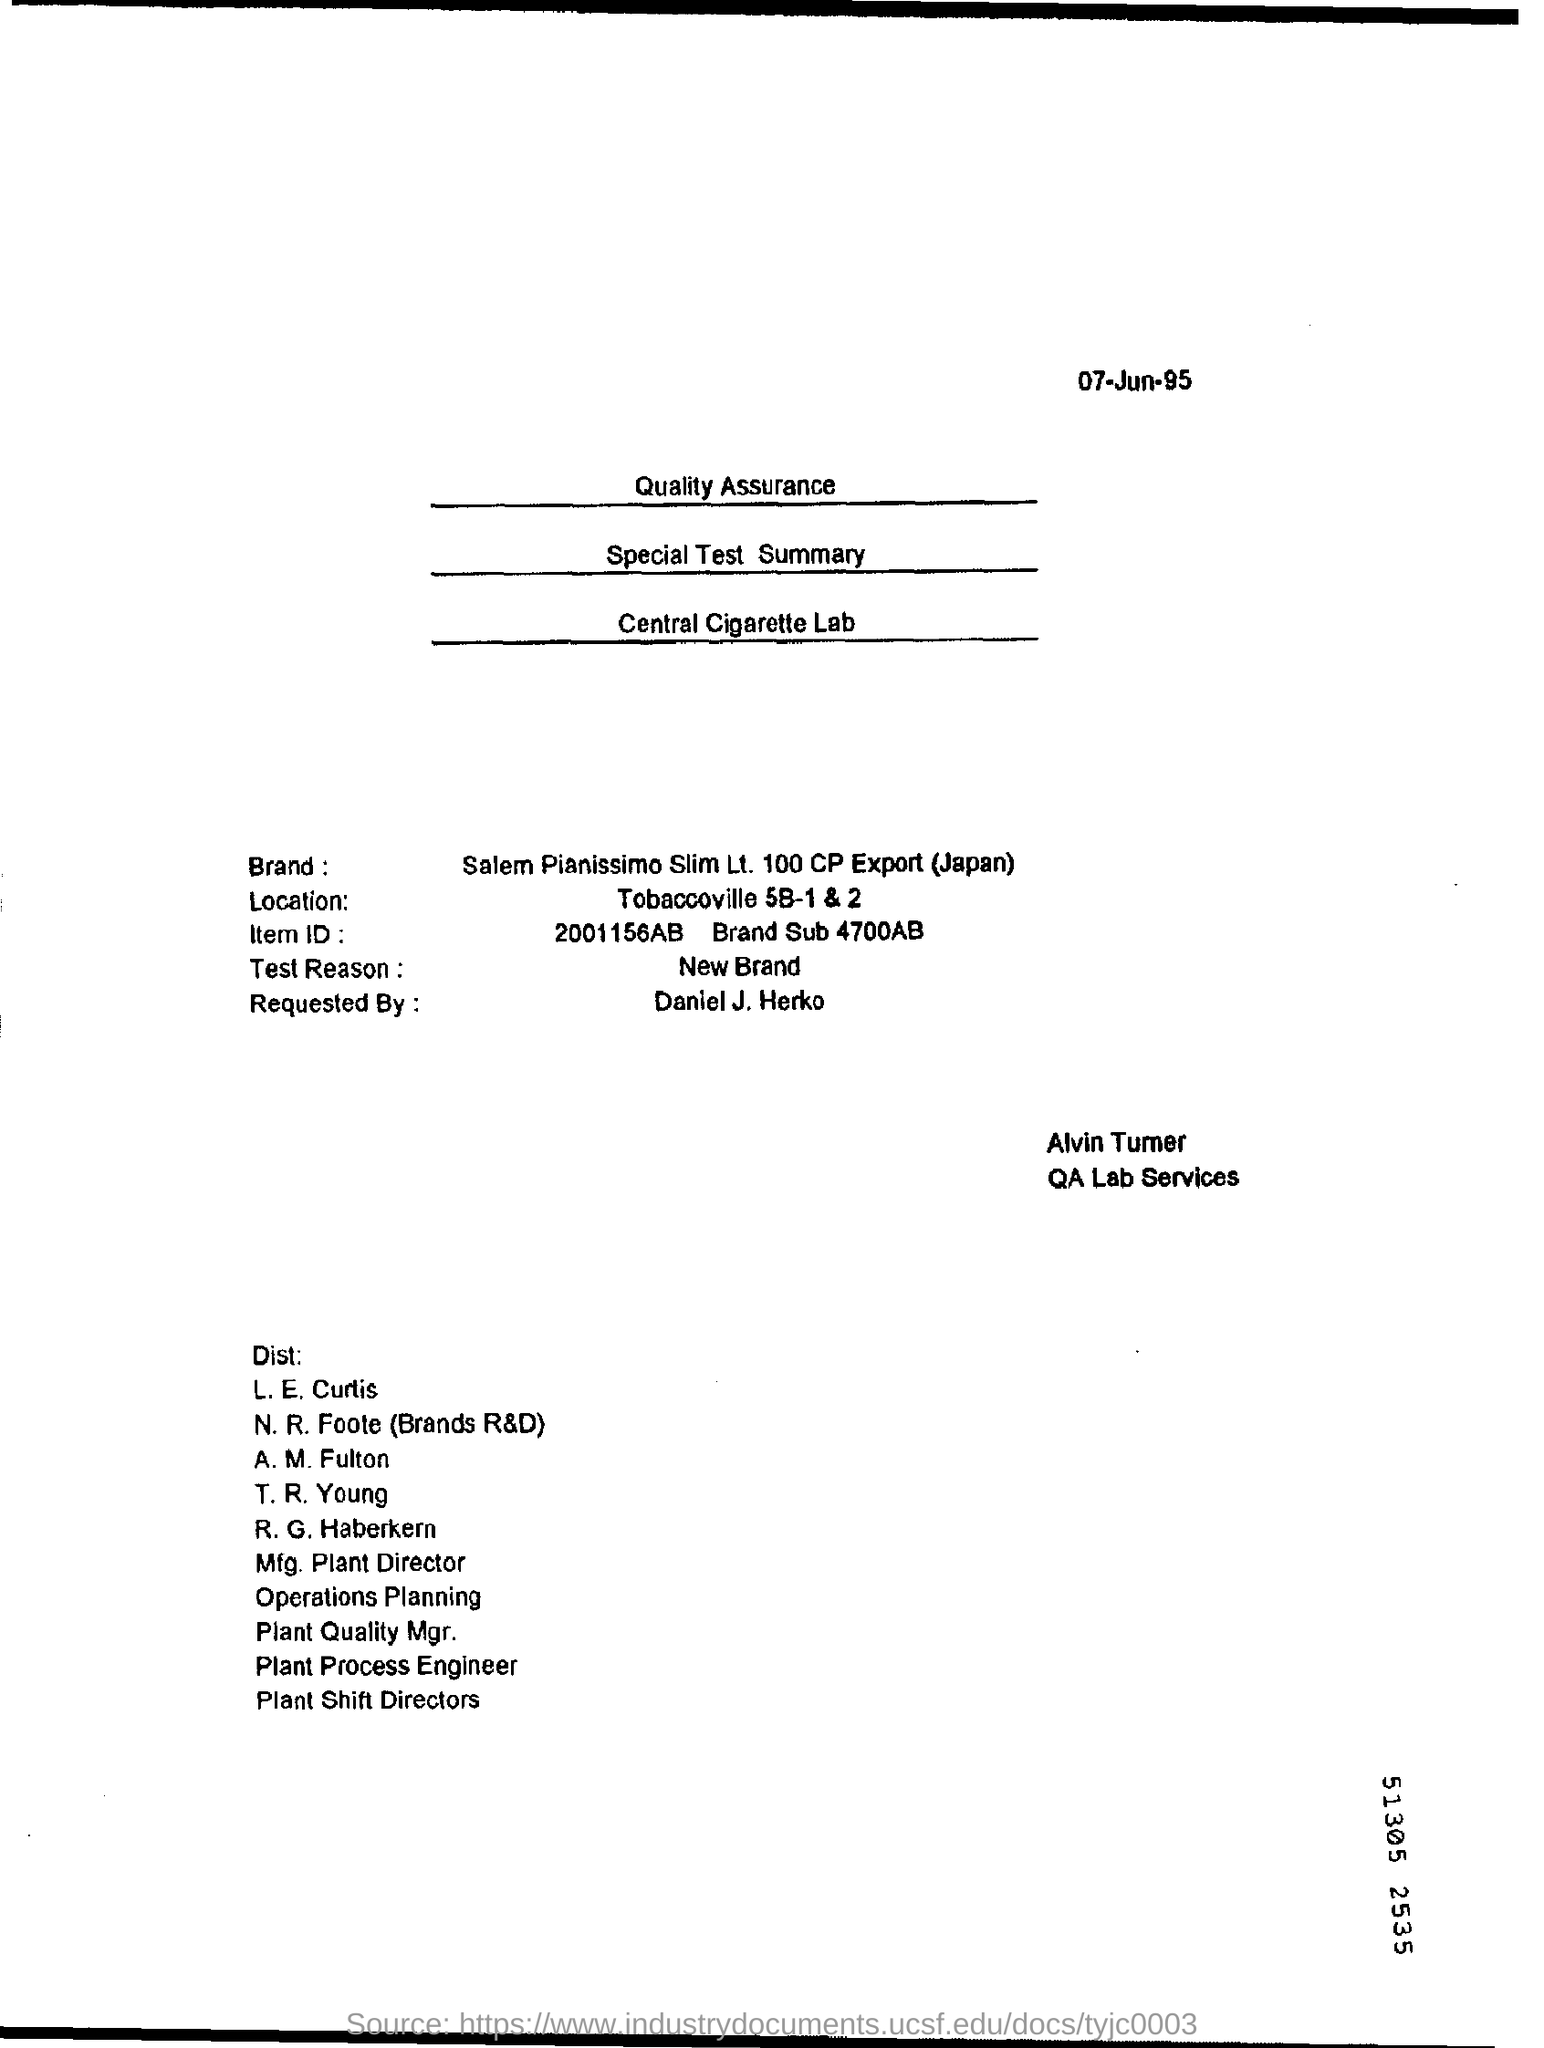What is the date mentioned in the top of the document ?
Your answer should be compact. 07-Jun-95. What is the Location ?
Keep it short and to the point. Tobaccoville 5B-1 & 2. What type of Test Reason is mentioned in this Document ?
Provide a short and direct response. New Brand. 